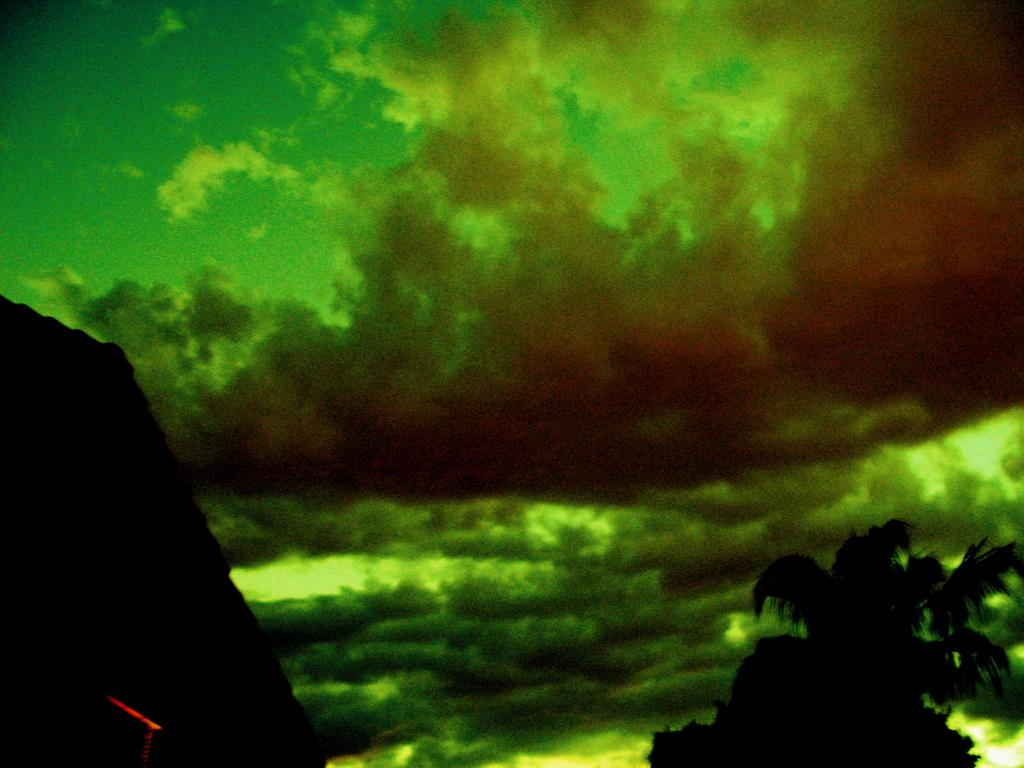What type of vegetation can be seen in the image? There are trees in the image. What can be seen in the sky in the image? There are clouds in the sky in the image. How many bears are visible in the image? There are no bears present in the image. What type of quiver can be seen in the image? There is no quiver present in the image. 